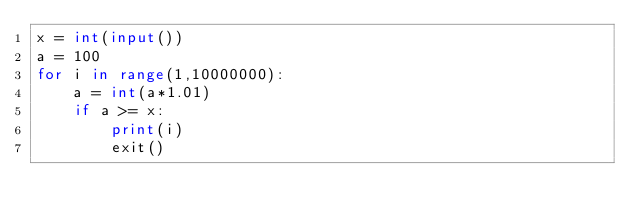<code> <loc_0><loc_0><loc_500><loc_500><_Python_>x = int(input())
a = 100
for i in range(1,10000000):
    a = int(a*1.01)
    if a >= x:
        print(i)
        exit()</code> 